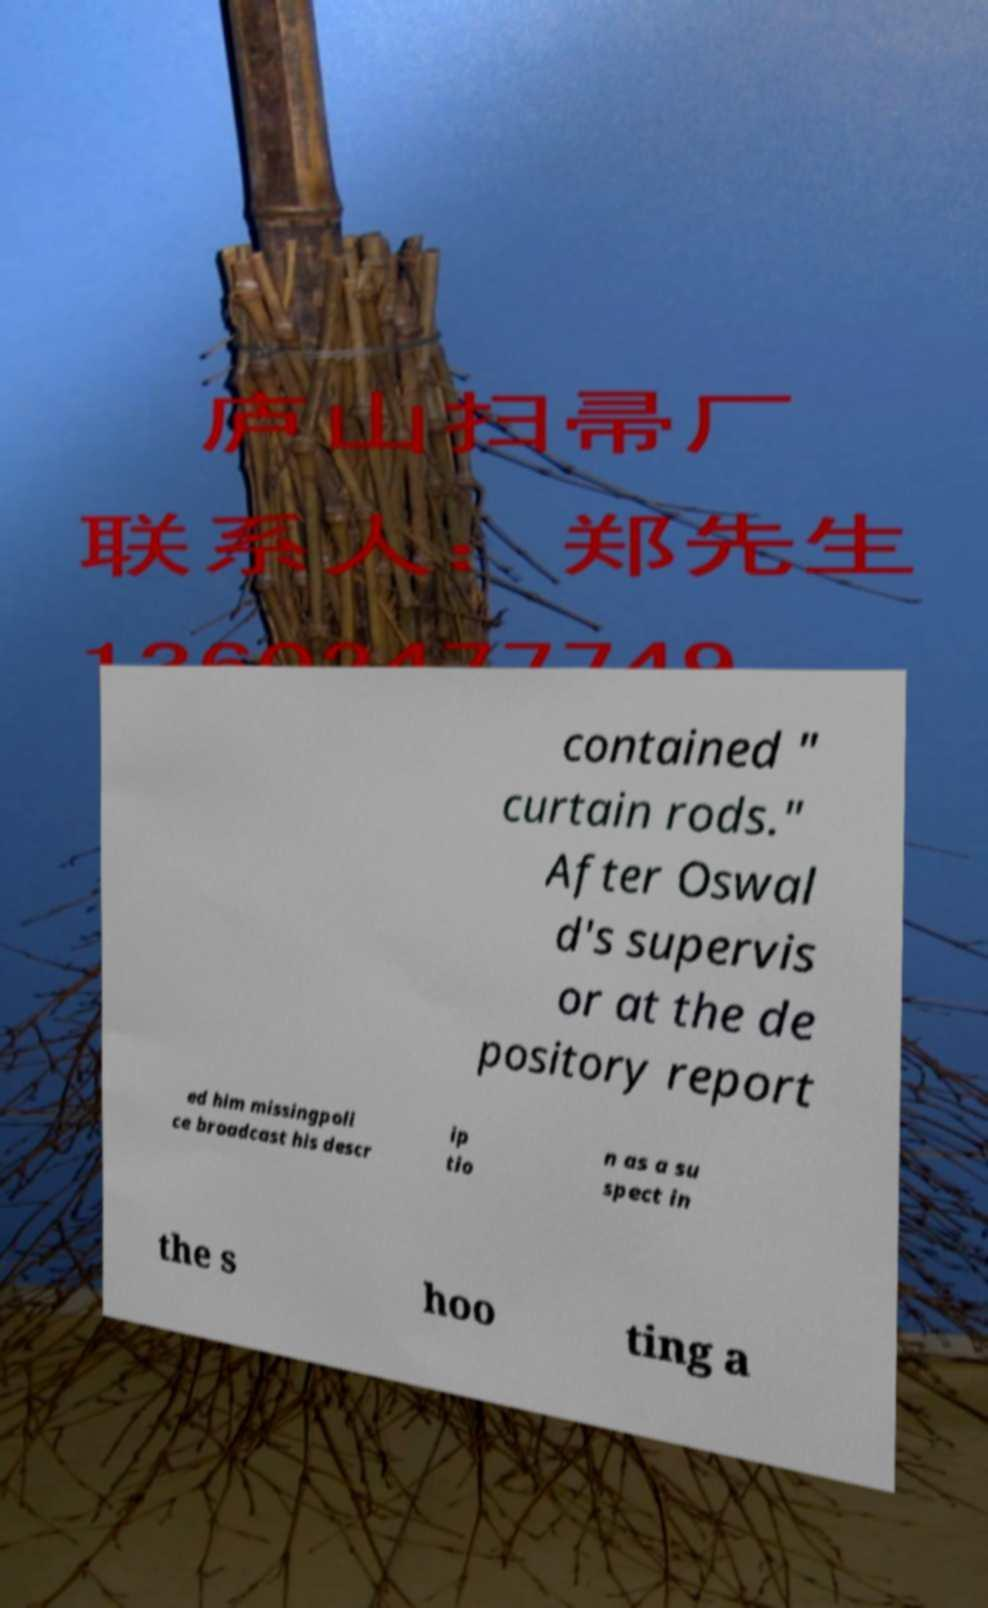What messages or text are displayed in this image? I need them in a readable, typed format. contained " curtain rods." After Oswal d's supervis or at the de pository report ed him missingpoli ce broadcast his descr ip tio n as a su spect in the s hoo ting a 